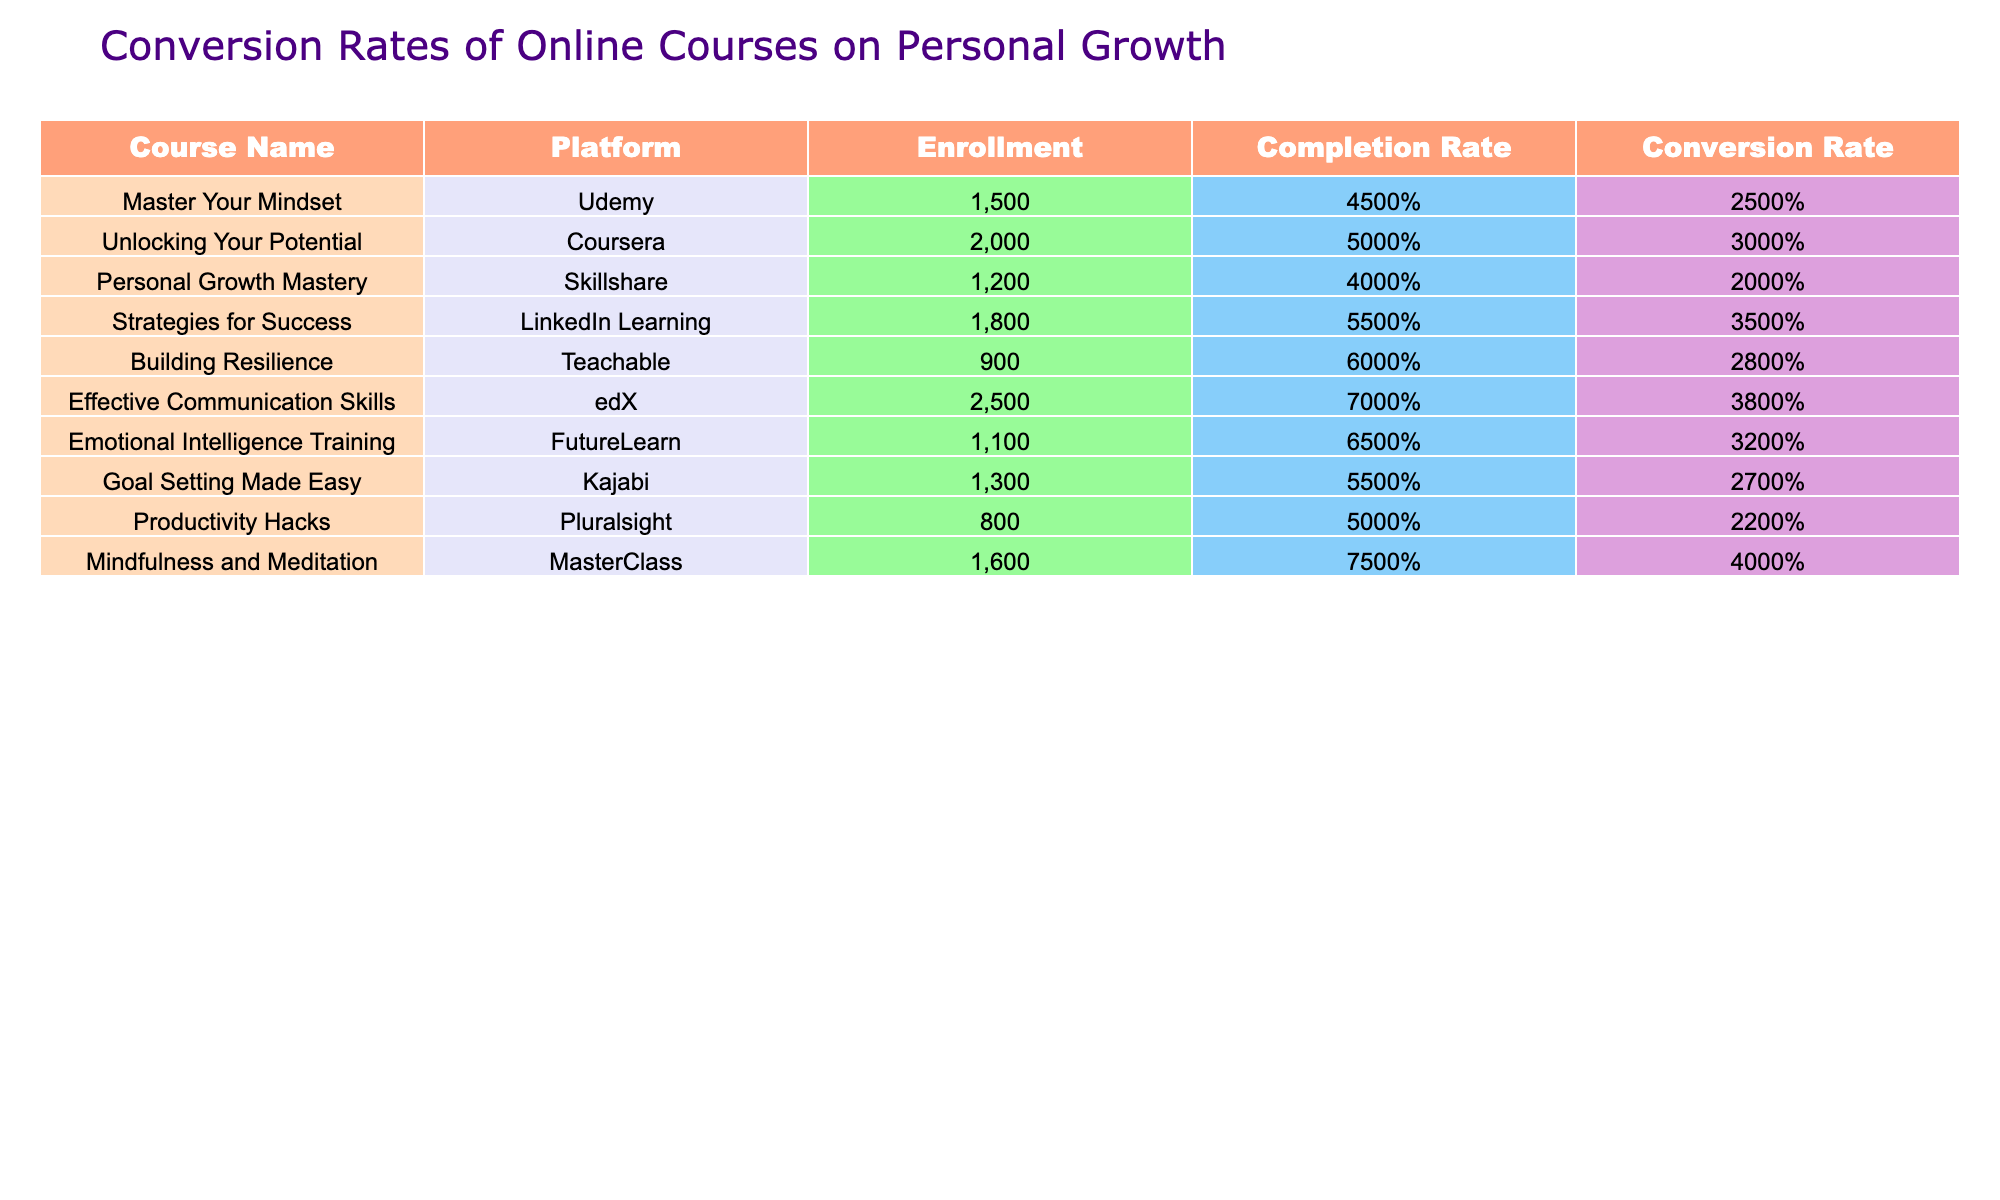What is the enrollment count for the course "Mindfulness and Meditation"? The enrollment count for "Mindfulness and Meditation" is provided directly in the table under the Enrollment column. It shows that there are 1,600 students enrolled in this course.
Answer: 1600 Which course has the highest conversion rate? To find the highest conversion rate, I need to compare the Conversion Rate entries in the table. The maximum value is 40% from the course "Mindfulness and Meditation."
Answer: Mindfulness and Meditation What is the average completion rate for all courses listed? To calculate the average completion rate, first, convert all rates from percentages: 45, 50, 40, 55, 60, 70, 65, 55, 50, and 75. Sum these values: 45 + 50 + 40 + 55 + 60 + 70 + 65 + 55 + 50 + 75 =  625. There are 10 courses, so the average is 625 / 10 = 62.5%.
Answer: 62.5% Is the conversion rate of "Effective Communication Skills" greater than that of "Productivity Hacks"? To answer this, I compare the Conversion Rates: "Effective Communication Skills" has a conversion rate of 38%, while "Productivity Hacks" has a rate of 22%. Since 38% is greater than 22%, the statement is true.
Answer: Yes What is the total enrollment number for courses on "Udemy" and "Skillshare"? The enrollment for "Master Your Mindset" (Udemy) is 1,500 and for "Personal Growth Mastery" (Skillshare) is 1,200. To find the total, I add these two numbers: 1,500 + 1,200 = 2,700.
Answer: 2700 Does "Unlocking Your Potential" have a higher enrollment than "Building Resilience"? "Unlocking Your Potential" has an enrollment of 2,000, while "Building Resilience" has 900. Since 2,000 is greater than 900, the answer is yes.
Answer: Yes What is the difference in conversion rates between "Strategies for Success" and "Emotional Intelligence Training"? The conversion rate for "Strategies for Success" is 35%, while for "Emotional Intelligence Training," it is 32%. The difference is calculated by subtracting 32 from 35, which results in 3%.
Answer: 3% Which platform has the highest average completion rate among the courses listed? I need to calculate the average completion rates for each platform by summing up the completion rates for courses on the same platform and dividing by the number of courses on that platform. For example, Udemy has one course with a completion rate of 45%. For Coursera, 50%. Skillshare has 40%. After calculating for all platforms, LinkedIn Learning has an average completion rate of 55%, which is the highest.
Answer: LinkedIn Learning What percentage of the total enrollment does the course "Goal Setting Made Easy" represent? The total enrollment for all courses is calculated by adding the individual enrollments: 1500 + 2000 + 1200 + 1800 + 900 + 2500 + 1100 + 1300 + 800 + 1600 = 13,700. The enrollment for "Goal Setting Made Easy" is 1,300. Thus, the percentage is (1300 / 13700) * 100 = 9.49%.
Answer: 9.49% 